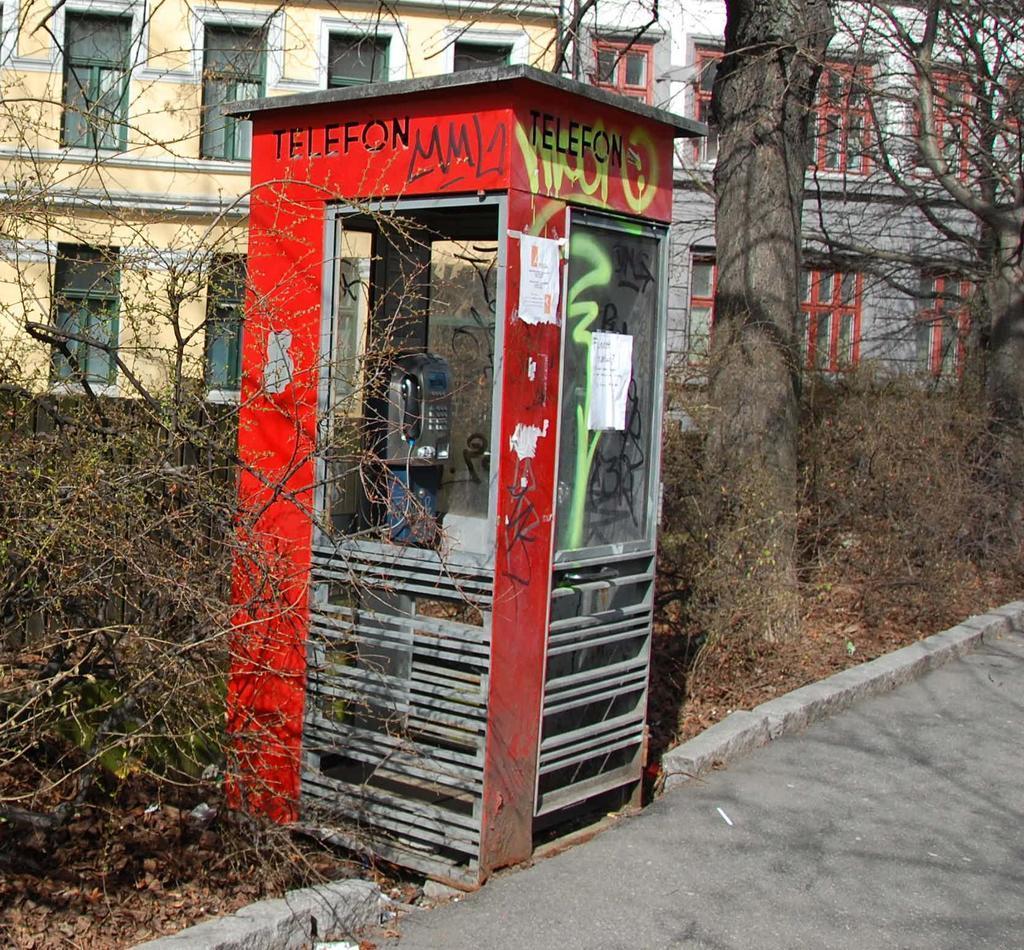In one or two sentences, can you explain what this image depicts? In this picture I can see a telephone booth with a telephone in it, there are plants, trees, and in the background there are buildings with windows. 